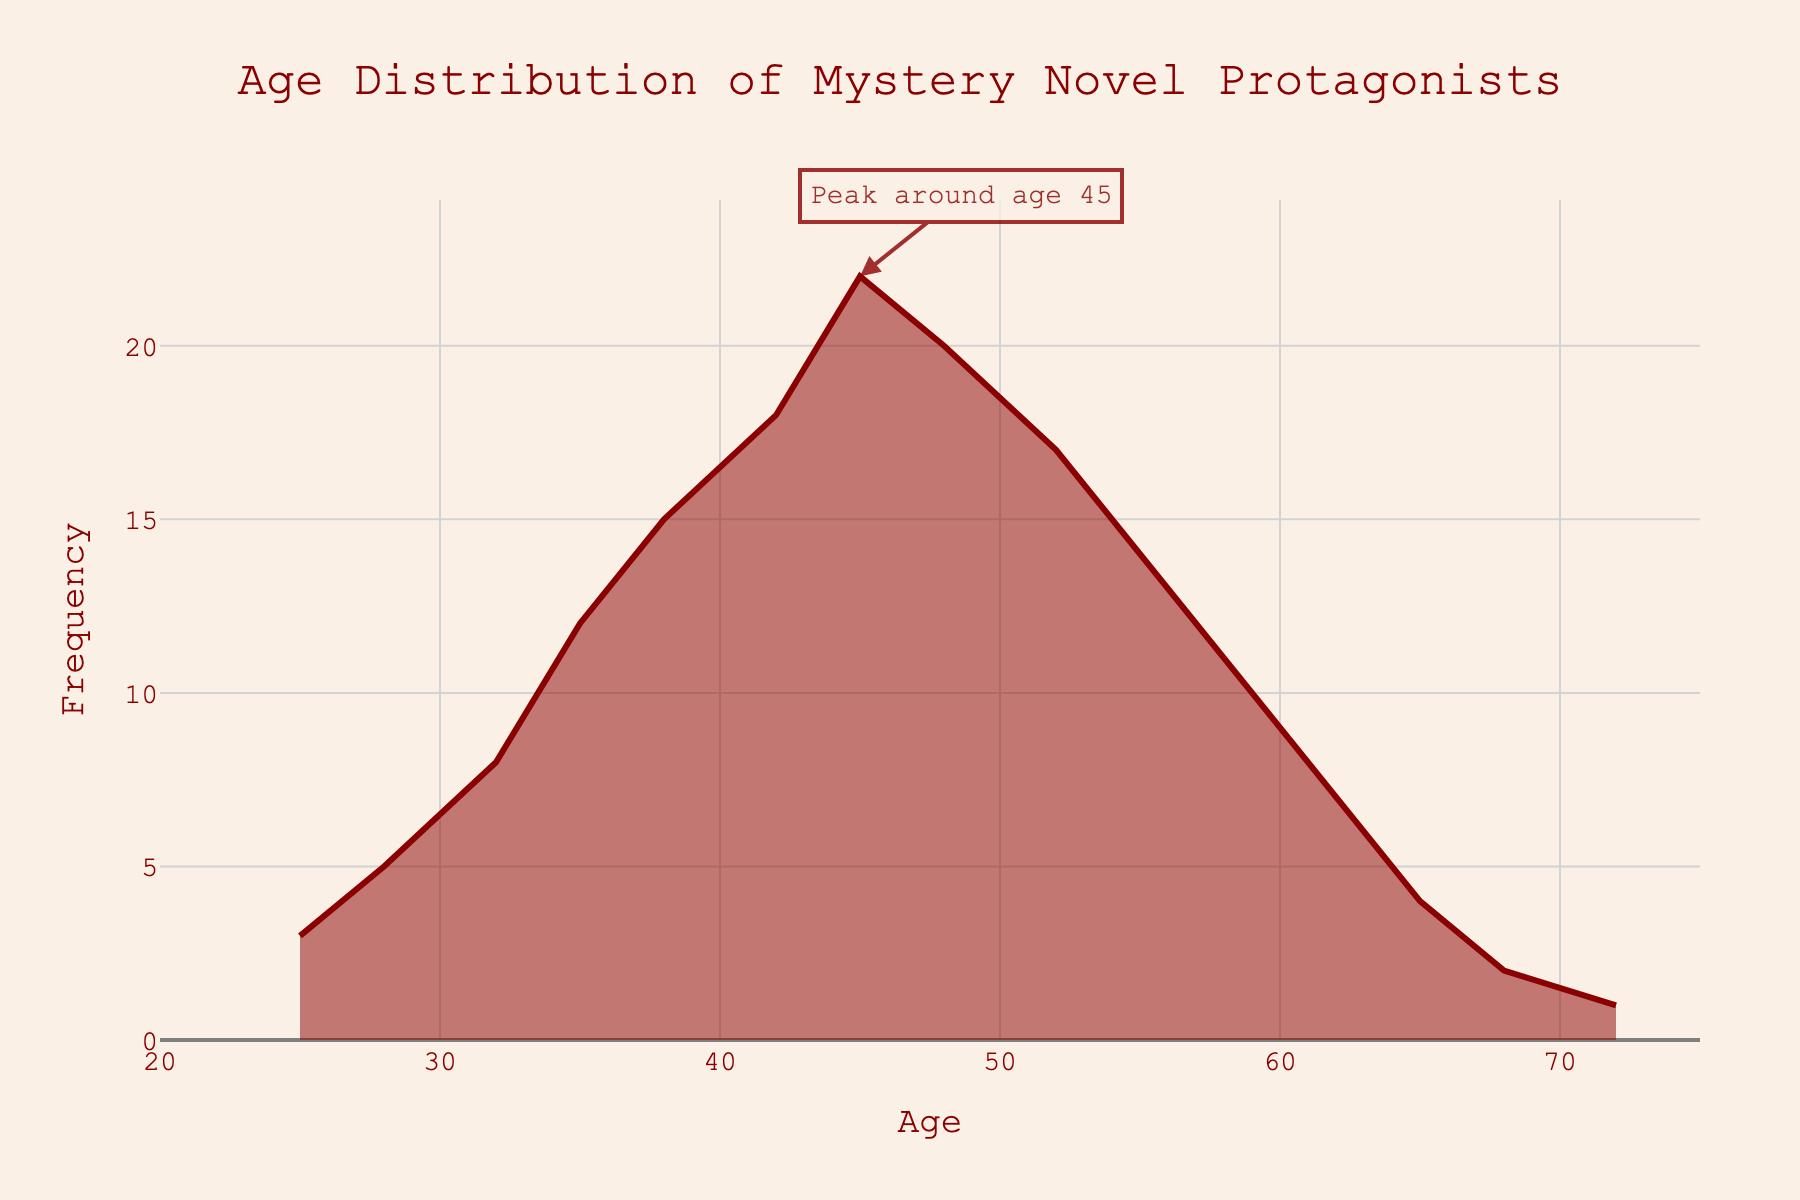Which age group has the highest frequency? The figure shows the highest point in the density plot corresponding to age 45, with a frequency of 22, which is also highlighted by an annotation.
Answer: Age 45 What is the title of the figure? The title is prominently displayed at the top center of the figure in dark red font.
Answer: Age Distribution of Mystery Novel Protagonists How many age groups have a frequency above 20? Observing the y-axis, it can be seen that the age groups 45 (with a frequency of 22) and 48 (with a frequency of 20) are above 20.
Answer: 2 What is the frequency for the age group 55? The frequency value of the age 55 can be checked on the plot, which shows it reaching 14.
Answer: 14 What can be inferred about protagonists aged 72? The density plot indicates a peak at age 72 with a very low frequency of 1, suggesting very few protagonists in this age group.
Answer: Very low frequency Which age group has the second-highest frequency? By examining the plot, the age group with the second highest frequency after 45 is age 48, with a frequency of 20.
Answer: Age 48 By how much does the frequency increase from age 35 to age 42? The y-values show the frequency at age 35 is 12 and at age 42 is 18. The difference is 18 - 12 = 6.
Answer: 6 Which age group shows the steepest increase in frequency? Observing the slope of the plot, the steepest increase appears between age 35 and age 45, where the frequency rises significantly from 12 to 22.
Answer: Age 35 to Age 45 What is the age range covered in the plot? The x-axis shows that the age range in the plot goes from 25 to 72 years.
Answer: 25 to 72 years What is the general trend for the frequency after age 45? After the peak frequency at age 45, the frequency generally shows a decreasing trend.
Answer: Decreasing 